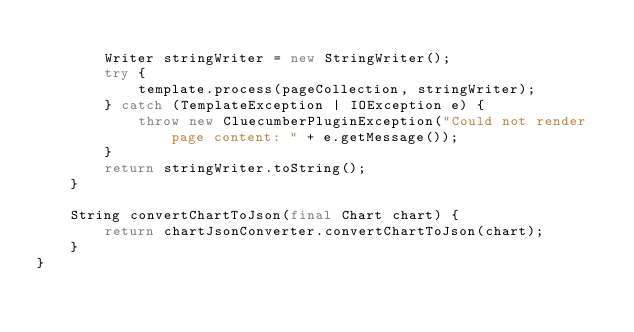Convert code to text. <code><loc_0><loc_0><loc_500><loc_500><_Java_>
        Writer stringWriter = new StringWriter();
        try {
            template.process(pageCollection, stringWriter);
        } catch (TemplateException | IOException e) {
            throw new CluecumberPluginException("Could not render page content: " + e.getMessage());
        }
        return stringWriter.toString();
    }

    String convertChartToJson(final Chart chart) {
        return chartJsonConverter.convertChartToJson(chart);
    }
}
</code> 